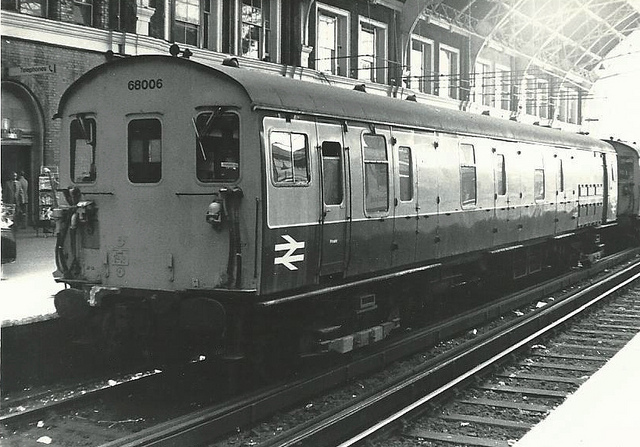Read all the text in this image. 68006 